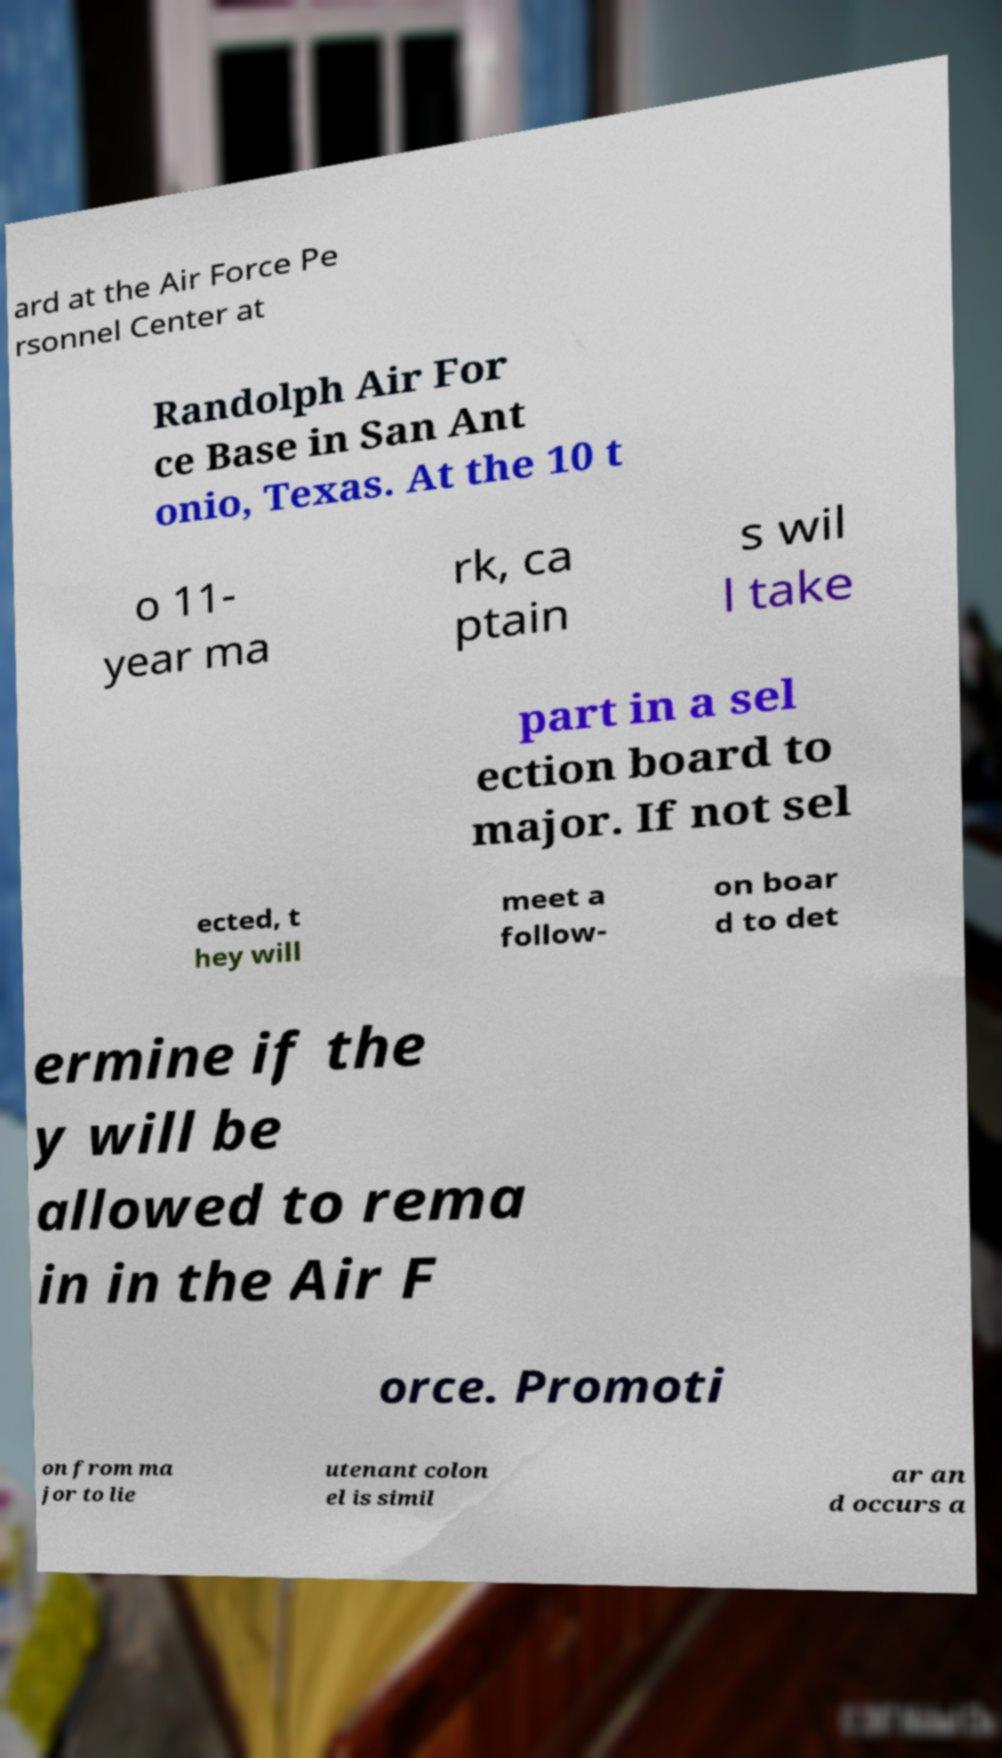Can you accurately transcribe the text from the provided image for me? ard at the Air Force Pe rsonnel Center at Randolph Air For ce Base in San Ant onio, Texas. At the 10 t o 11- year ma rk, ca ptain s wil l take part in a sel ection board to major. If not sel ected, t hey will meet a follow- on boar d to det ermine if the y will be allowed to rema in in the Air F orce. Promoti on from ma jor to lie utenant colon el is simil ar an d occurs a 